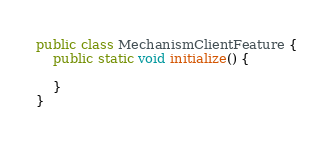Convert code to text. <code><loc_0><loc_0><loc_500><loc_500><_Java_>public class MechanismClientFeature {
    public static void initialize() {

    }
}
</code> 